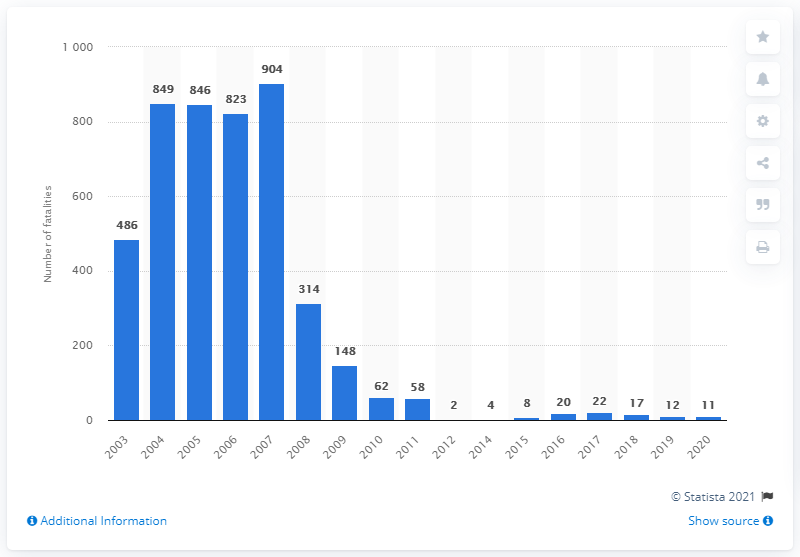List a handful of essential elements in this visual. In 2007, 904 U.S. soldiers lost their lives while serving in Iraq. In the year 2021, 11 U.S. soldiers lost their lives while serving in Iraq. 